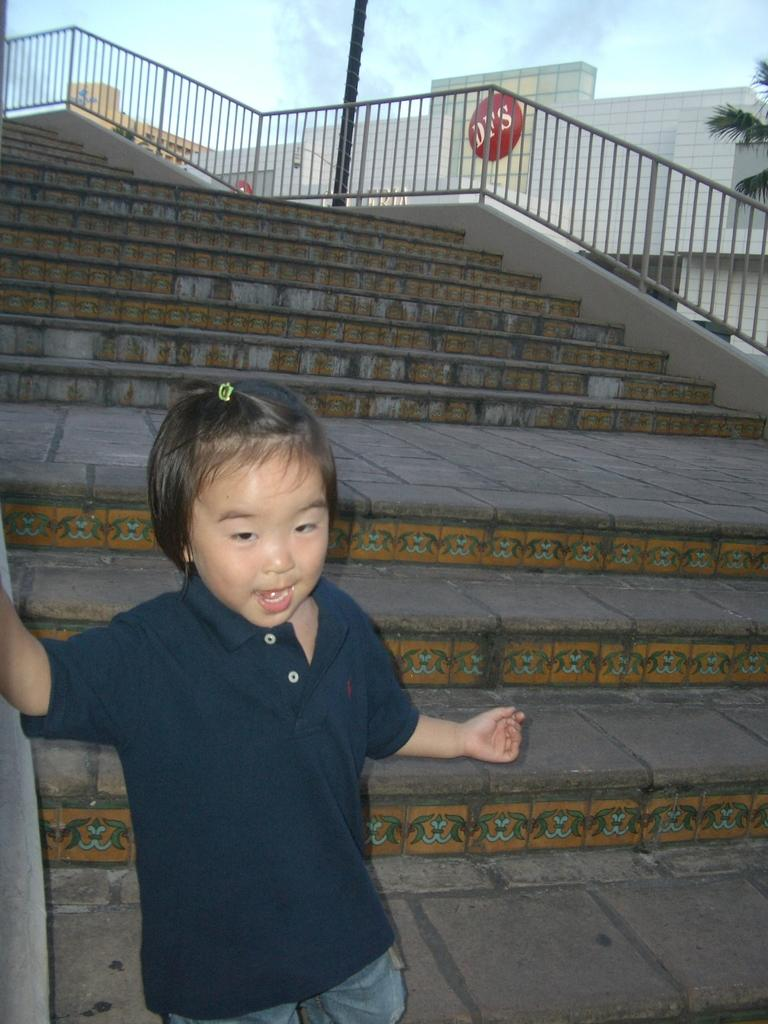What type of structure is present in the image? There are stairs in the image. Who is present in the image? There is a boy in the image. What can be seen in the background of the image? There are buildings and trees in the image. How would you describe the sky in the image? The sky is blue and cloudy in the image. How many pancakes is the boy holding in the image? There are no pancakes present in the image. What is the boy's attention focused on in the image? The provided facts do not mention the boy's attention, so we cannot definitively answer this question. 